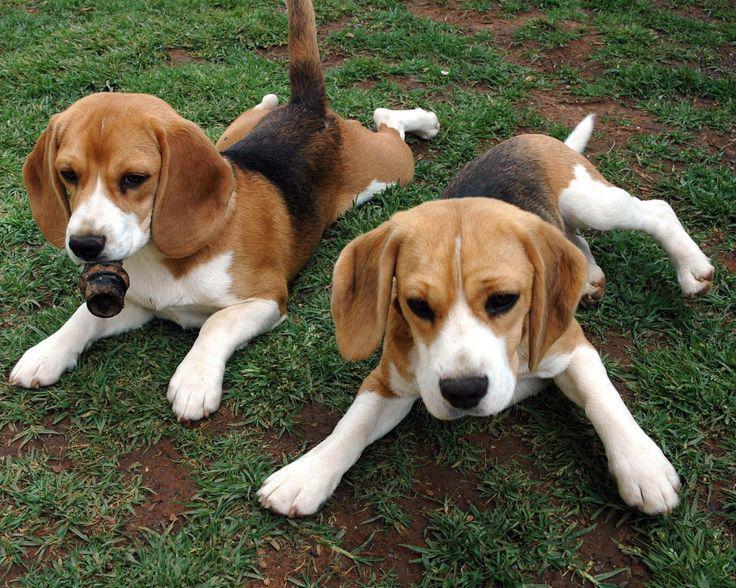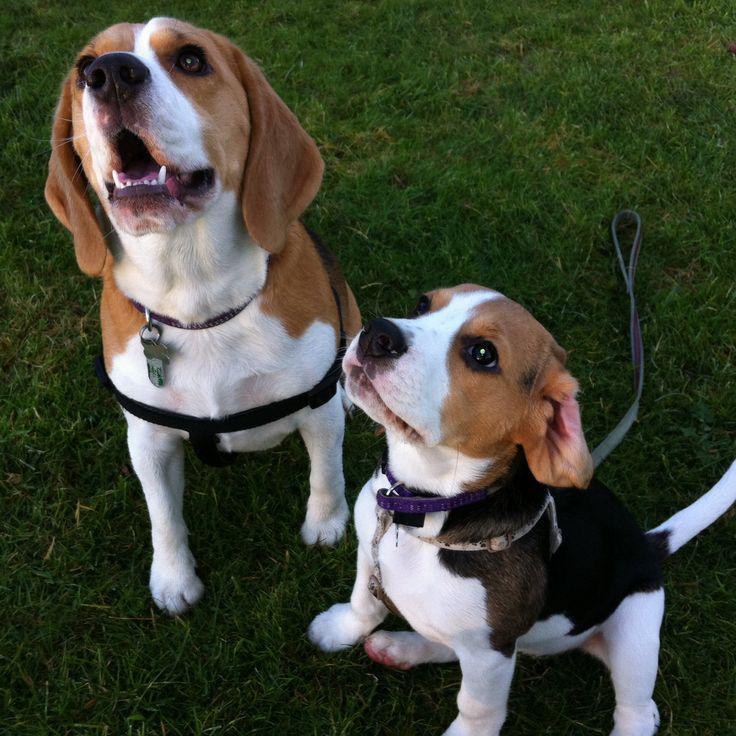The first image is the image on the left, the second image is the image on the right. Considering the images on both sides, is "The right image contains exactly two dogs." valid? Answer yes or no. Yes. The first image is the image on the left, the second image is the image on the right. Examine the images to the left and right. Is the description "One image contains twice as many beagles as the other, and the combined images total three dogs." accurate? Answer yes or no. No. 